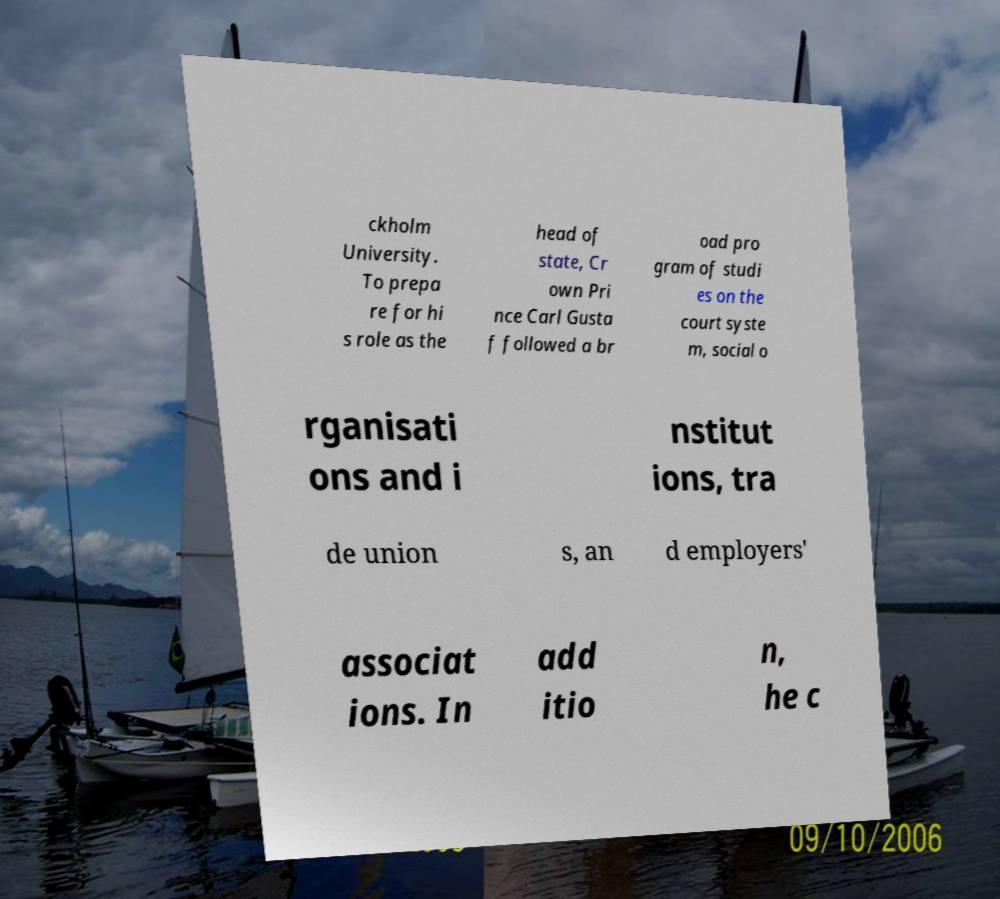Can you accurately transcribe the text from the provided image for me? ckholm University. To prepa re for hi s role as the head of state, Cr own Pri nce Carl Gusta f followed a br oad pro gram of studi es on the court syste m, social o rganisati ons and i nstitut ions, tra de union s, an d employers' associat ions. In add itio n, he c 